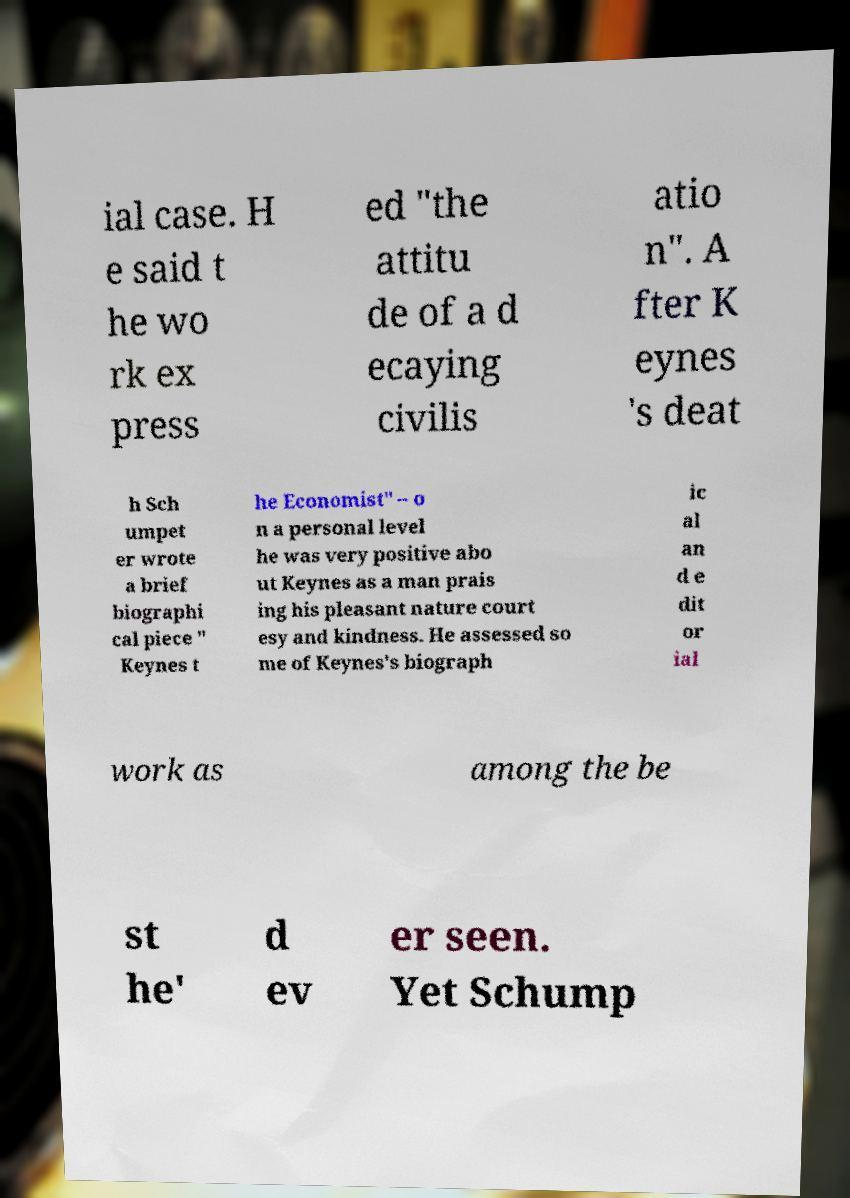For documentation purposes, I need the text within this image transcribed. Could you provide that? ial case. H e said t he wo rk ex press ed "the attitu de of a d ecaying civilis atio n". A fter K eynes 's deat h Sch umpet er wrote a brief biographi cal piece " Keynes t he Economist" – o n a personal level he was very positive abo ut Keynes as a man prais ing his pleasant nature court esy and kindness. He assessed so me of Keynes's biograph ic al an d e dit or ial work as among the be st he' d ev er seen. Yet Schump 